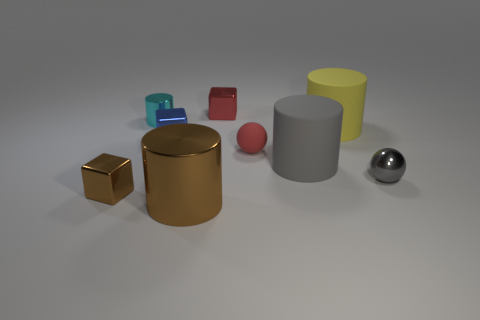Is there a cyan cylinder made of the same material as the large brown object?
Make the answer very short. Yes. The large metal cylinder is what color?
Keep it short and to the point. Brown. There is a metal object that is on the right side of the small red thing that is behind the tiny red object on the right side of the red shiny block; what is its size?
Your response must be concise. Small. How many other objects are the same shape as the large shiny object?
Your answer should be very brief. 3. What color is the cylinder that is behind the small rubber thing and right of the small cyan metallic cylinder?
Offer a very short reply. Yellow. Are there any other things that are the same size as the red rubber sphere?
Offer a very short reply. Yes. There is a matte thing that is behind the small red rubber object; is its color the same as the shiny sphere?
Provide a short and direct response. No. How many cylinders are either large brown metal objects or cyan objects?
Give a very brief answer. 2. The brown object to the right of the small blue shiny object has what shape?
Ensure brevity in your answer.  Cylinder. What is the color of the block that is in front of the big rubber thing in front of the tiny red thing in front of the tiny red shiny object?
Your answer should be very brief. Brown. 